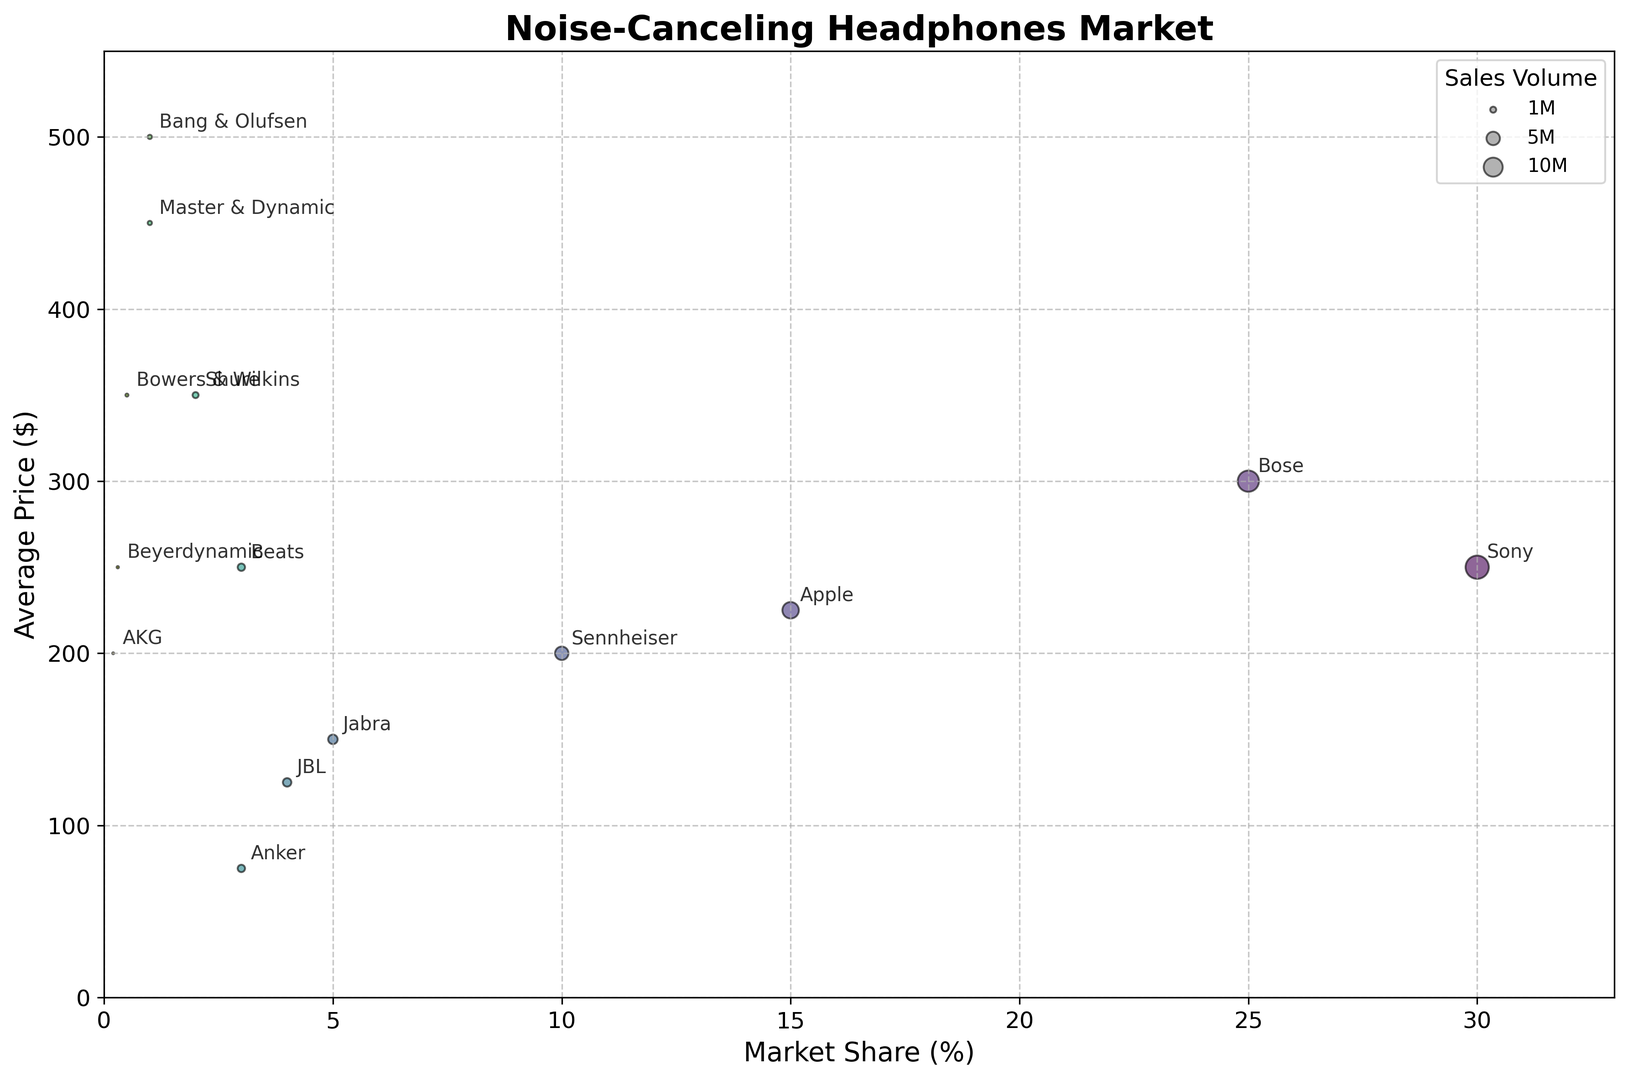What is the average market share of the brands that have a price range of $200-$300? Identify the brands within the $200-$300 price range, which are Sony, Beats, and Beyerdynamic. Their respective market shares are 30%, 3%, and 0.3%. Average them to get (30 + 3 + 0.3) / 3 = 11.1%.
Answer: 11.1% Which brand has the highest average price? Identify the brand with the highest y-value (average price), which is Bang & Olufsen. It has an average price range of $400-$600.
Answer: Bang & Olufsen Which brand has the largest sales volume in the $150-$250 price range? Look at the Y-axis range between $150 and $250, then identify the brand with the largest bubble within that range. Apple has the largest bubble and sales volume of 7.5 million in this price range.
Answer: Apple Is there any brand with a sales volume below 1 million? If yes, name them. Identify brands with the smallest bubble size and check their sales volume. Shure, Master & Dynamic, Bang & Olufsen, Bowers & Wilkins, Beyerdynamic, and AKG all have sales volumes below 1 million.
Answer: Shure, Master & Dynamic, Bang & Olufsen, Bowers & Wilkins, Beyerdynamic, AKG How does the average price of Sennheiser compare to that of Jabra? Check the Y-axis values for both brands. Sennheiser's average price is in the $150-$250 range (average = $200), while Jabra's is in the $100-$200 range (average = $150). $200 is higher than $150.
Answer: Sennheiser has a higher average price than Jabra Which brand has a market share close to the average of Apple and Bose? Calculate the average of Apple and Bose's market shares: (15% + 25%) / 2 = 20%. Identify the brand with a market share close to 20%, which is none of the brands in the figure.
Answer: None Are there any brands that have both a high market share and a high average price? Identify brands with bubbles in the upper-right quadrant of the figure. Sony and Bose have high market shares (30% and 25%) and higher average prices ($200-$300 and $250-$350).
Answer: Sony and Bose What is the difference in market share between Sony and Anker? Sony has a market share of 30%, and Anker has a market share of 3%. Calculate the difference: 30% - 3% = 27%.
Answer: 27% Which brand's average price range is closest to $300? Identify the brand whose bubble is closest to the $300 mark on the Y-axis. Shure and Bowers & Wilkins are close to $300.
Answer: Shure and Bowers & Wilkins Does any brand have an average price above $400 and a sales volume of less than 1 million? Identify bubbles in the Y-axis range above $400 that are small in size. Bang & Olufsen and Master & Dynamic fit this description with sales volumes of 500,000 and 500,000, respectively.
Answer: Bang & Olufsen and Master & Dynamic 